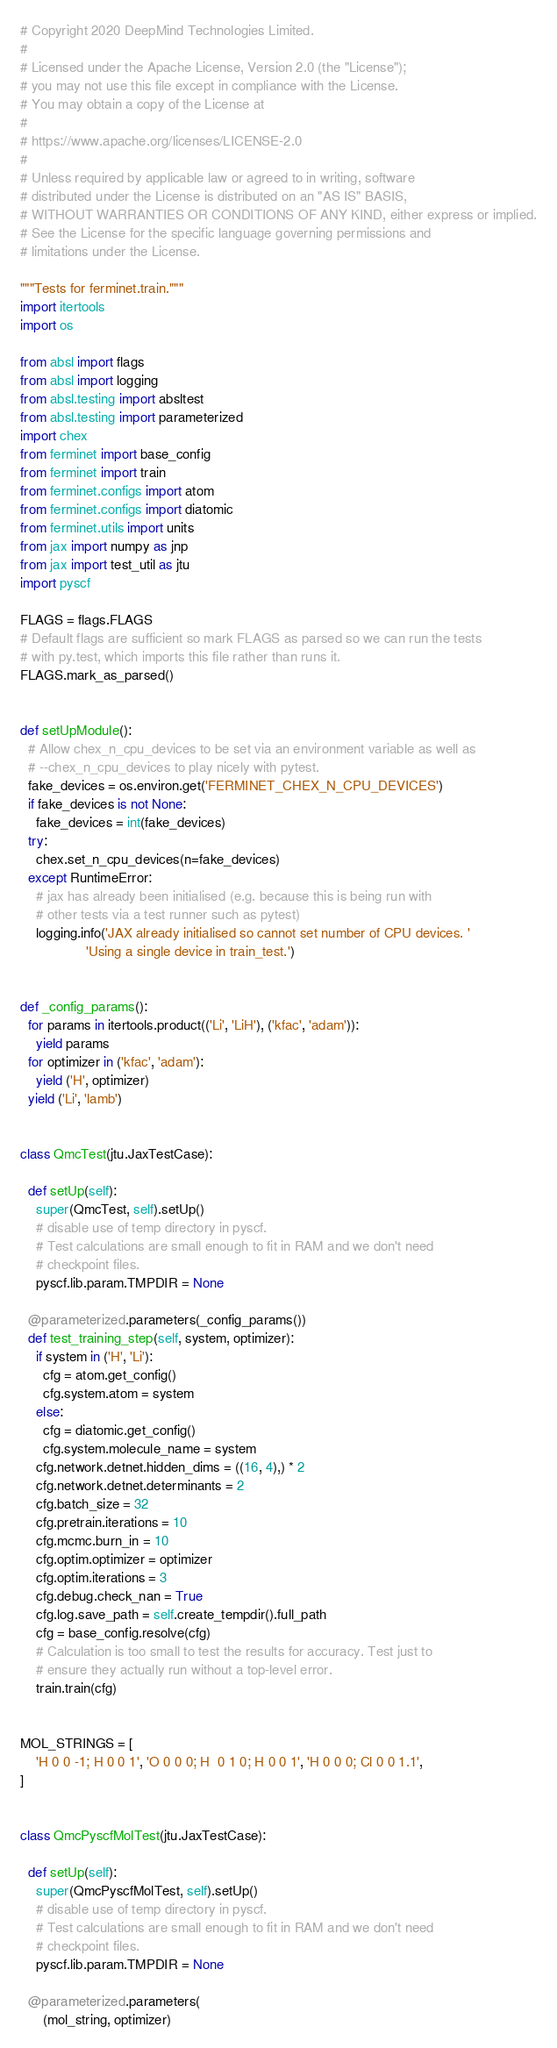<code> <loc_0><loc_0><loc_500><loc_500><_Python_># Copyright 2020 DeepMind Technologies Limited.
#
# Licensed under the Apache License, Version 2.0 (the "License");
# you may not use this file except in compliance with the License.
# You may obtain a copy of the License at
#
# https://www.apache.org/licenses/LICENSE-2.0
#
# Unless required by applicable law or agreed to in writing, software
# distributed under the License is distributed on an "AS IS" BASIS,
# WITHOUT WARRANTIES OR CONDITIONS OF ANY KIND, either express or implied.
# See the License for the specific language governing permissions and
# limitations under the License.

"""Tests for ferminet.train."""
import itertools
import os

from absl import flags
from absl import logging
from absl.testing import absltest
from absl.testing import parameterized
import chex
from ferminet import base_config
from ferminet import train
from ferminet.configs import atom
from ferminet.configs import diatomic
from ferminet.utils import units
from jax import numpy as jnp
from jax import test_util as jtu
import pyscf

FLAGS = flags.FLAGS
# Default flags are sufficient so mark FLAGS as parsed so we can run the tests
# with py.test, which imports this file rather than runs it.
FLAGS.mark_as_parsed()


def setUpModule():
  # Allow chex_n_cpu_devices to be set via an environment variable as well as
  # --chex_n_cpu_devices to play nicely with pytest.
  fake_devices = os.environ.get('FERMINET_CHEX_N_CPU_DEVICES')
  if fake_devices is not None:
    fake_devices = int(fake_devices)
  try:
    chex.set_n_cpu_devices(n=fake_devices)
  except RuntimeError:
    # jax has already been initialised (e.g. because this is being run with
    # other tests via a test runner such as pytest)
    logging.info('JAX already initialised so cannot set number of CPU devices. '
                 'Using a single device in train_test.')


def _config_params():
  for params in itertools.product(('Li', 'LiH'), ('kfac', 'adam')):
    yield params
  for optimizer in ('kfac', 'adam'):
    yield ('H', optimizer)
  yield ('Li', 'lamb')


class QmcTest(jtu.JaxTestCase):

  def setUp(self):
    super(QmcTest, self).setUp()
    # disable use of temp directory in pyscf.
    # Test calculations are small enough to fit in RAM and we don't need
    # checkpoint files.
    pyscf.lib.param.TMPDIR = None

  @parameterized.parameters(_config_params())
  def test_training_step(self, system, optimizer):
    if system in ('H', 'Li'):
      cfg = atom.get_config()
      cfg.system.atom = system
    else:
      cfg = diatomic.get_config()
      cfg.system.molecule_name = system
    cfg.network.detnet.hidden_dims = ((16, 4),) * 2
    cfg.network.detnet.determinants = 2
    cfg.batch_size = 32
    cfg.pretrain.iterations = 10
    cfg.mcmc.burn_in = 10
    cfg.optim.optimizer = optimizer
    cfg.optim.iterations = 3
    cfg.debug.check_nan = True
    cfg.log.save_path = self.create_tempdir().full_path
    cfg = base_config.resolve(cfg)
    # Calculation is too small to test the results for accuracy. Test just to
    # ensure they actually run without a top-level error.
    train.train(cfg)


MOL_STRINGS = [
    'H 0 0 -1; H 0 0 1', 'O 0 0 0; H  0 1 0; H 0 0 1', 'H 0 0 0; Cl 0 0 1.1',
]


class QmcPyscfMolTest(jtu.JaxTestCase):

  def setUp(self):
    super(QmcPyscfMolTest, self).setUp()
    # disable use of temp directory in pyscf.
    # Test calculations are small enough to fit in RAM and we don't need
    # checkpoint files.
    pyscf.lib.param.TMPDIR = None

  @parameterized.parameters(
      (mol_string, optimizer)</code> 